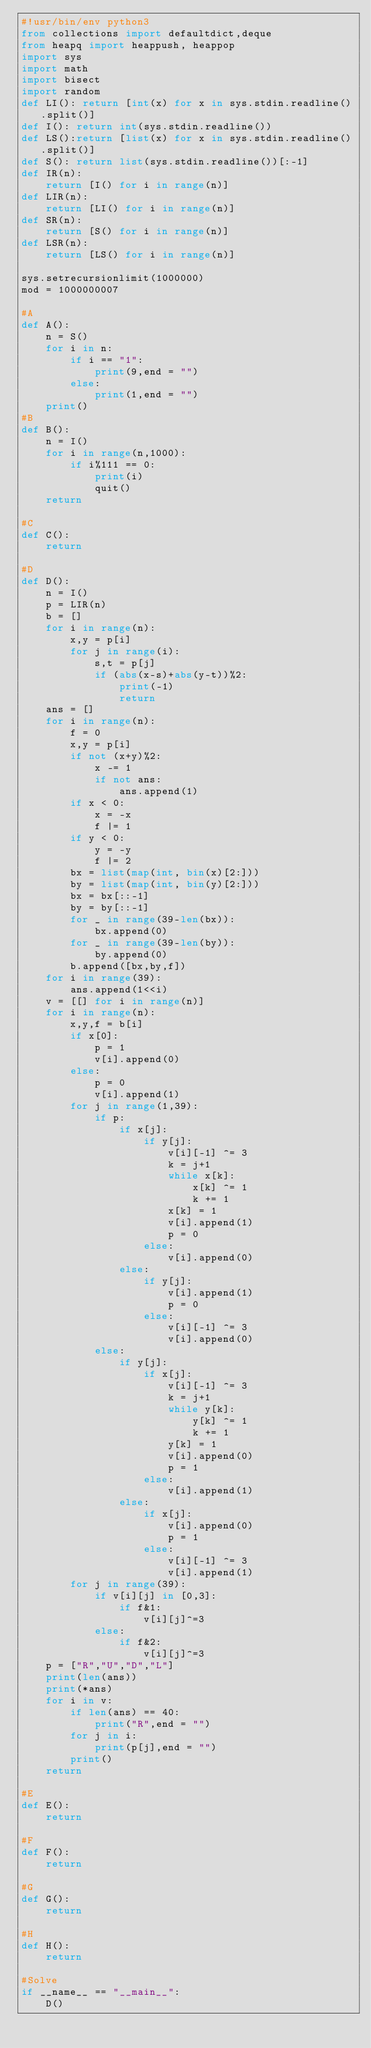Convert code to text. <code><loc_0><loc_0><loc_500><loc_500><_Python_>#!usr/bin/env python3
from collections import defaultdict,deque
from heapq import heappush, heappop
import sys
import math
import bisect
import random
def LI(): return [int(x) for x in sys.stdin.readline().split()]
def I(): return int(sys.stdin.readline())
def LS():return [list(x) for x in sys.stdin.readline().split()]
def S(): return list(sys.stdin.readline())[:-1]
def IR(n):
    return [I() for i in range(n)]
def LIR(n):
    return [LI() for i in range(n)]
def SR(n):
    return [S() for i in range(n)]
def LSR(n):
    return [LS() for i in range(n)]

sys.setrecursionlimit(1000000)
mod = 1000000007

#A
def A():
    n = S()
    for i in n:
        if i == "1":
            print(9,end = "")
        else:
            print(1,end = "")
    print()
#B
def B():
    n = I()
    for i in range(n,1000):
        if i%111 == 0:
            print(i)
            quit()
    return

#C
def C():
    return

#D
def D():
    n = I()
    p = LIR(n)
    b = []
    for i in range(n):
        x,y = p[i]
        for j in range(i):
            s,t = p[j]
            if (abs(x-s)+abs(y-t))%2:
                print(-1)
                return
    ans = []
    for i in range(n):
        f = 0
        x,y = p[i]
        if not (x+y)%2:
            x -= 1
            if not ans:
                ans.append(1)
        if x < 0:
            x = -x
            f |= 1
        if y < 0:
            y = -y
            f |= 2
        bx = list(map(int, bin(x)[2:]))
        by = list(map(int, bin(y)[2:]))
        bx = bx[::-1]
        by = by[::-1]
        for _ in range(39-len(bx)):
            bx.append(0)
        for _ in range(39-len(by)):
            by.append(0)
        b.append([bx,by,f])
    for i in range(39):
        ans.append(1<<i)
    v = [[] for i in range(n)]
    for i in range(n):
        x,y,f = b[i]
        if x[0]:
            p = 1
            v[i].append(0)
        else:
            p = 0
            v[i].append(1)
        for j in range(1,39):
            if p:
                if x[j]:
                    if y[j]:
                        v[i][-1] ^= 3
                        k = j+1
                        while x[k]:
                            x[k] ^= 1
                            k += 1
                        x[k] = 1
                        v[i].append(1)
                        p = 0
                    else:
                        v[i].append(0)
                else:
                    if y[j]:
                        v[i].append(1)
                        p = 0
                    else:
                        v[i][-1] ^= 3
                        v[i].append(0)
            else:
                if y[j]:
                    if x[j]:
                        v[i][-1] ^= 3
                        k = j+1
                        while y[k]:
                            y[k] ^= 1
                            k += 1
                        y[k] = 1
                        v[i].append(0)
                        p = 1
                    else:
                        v[i].append(1)
                else:
                    if x[j]:
                        v[i].append(0)
                        p = 1
                    else:
                        v[i][-1] ^= 3
                        v[i].append(1)
        for j in range(39):
            if v[i][j] in [0,3]:
                if f&1:
                    v[i][j]^=3
            else:
                if f&2:
                    v[i][j]^=3
    p = ["R","U","D","L"]
    print(len(ans))
    print(*ans)
    for i in v:
        if len(ans) == 40:
            print("R",end = "")
        for j in i:
            print(p[j],end = "")
        print()
    return

#E
def E():
    return

#F
def F():
    return

#G
def G():
    return

#H
def H():
    return

#Solve
if __name__ == "__main__":
    D()
</code> 